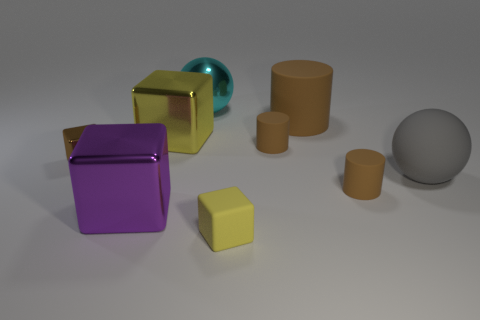Does the big yellow thing have the same material as the cyan sphere?
Your response must be concise. Yes. The cyan metallic ball is what size?
Offer a very short reply. Large. What number of big metal cubes have the same color as the big rubber cylinder?
Make the answer very short. 0. Is there a tiny thing that is on the right side of the yellow object right of the yellow block behind the large purple shiny block?
Your answer should be very brief. Yes. What is the shape of the purple thing that is the same size as the shiny ball?
Keep it short and to the point. Cube. How many tiny objects are cyan metal blocks or brown matte things?
Your response must be concise. 2. What color is the other big thing that is the same material as the gray object?
Ensure brevity in your answer.  Brown. Do the yellow thing that is right of the metal ball and the small object to the left of the tiny yellow rubber block have the same shape?
Provide a short and direct response. Yes. How many metal things are either large balls or purple objects?
Make the answer very short. 2. There is a small cube that is the same color as the big cylinder; what is its material?
Your response must be concise. Metal. 